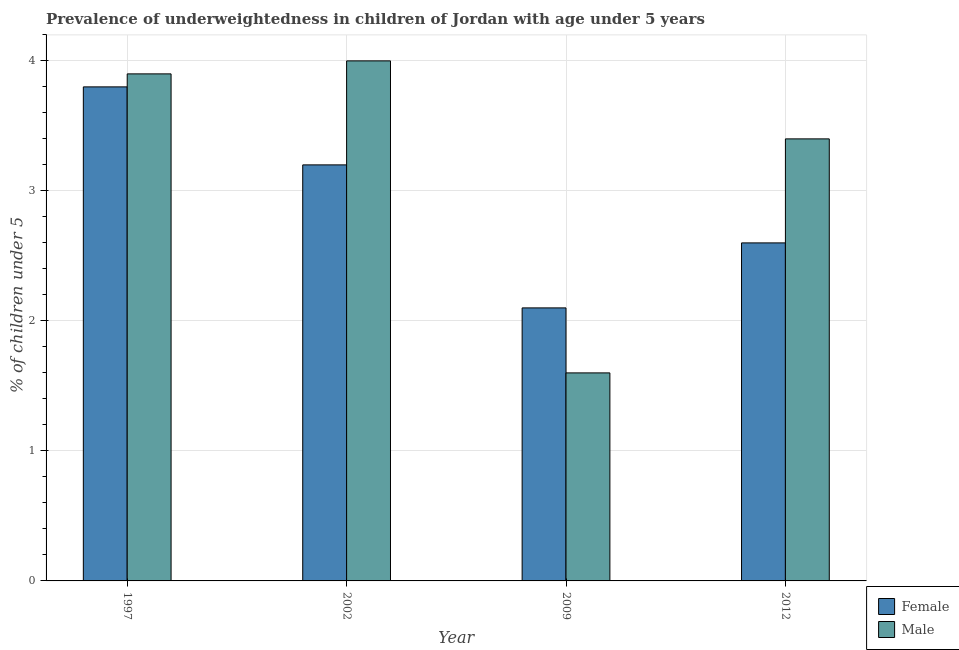How many different coloured bars are there?
Offer a terse response. 2. Are the number of bars on each tick of the X-axis equal?
Give a very brief answer. Yes. How many bars are there on the 2nd tick from the right?
Offer a terse response. 2. In how many cases, is the number of bars for a given year not equal to the number of legend labels?
Your answer should be very brief. 0. What is the percentage of underweighted female children in 2002?
Provide a short and direct response. 3.2. Across all years, what is the maximum percentage of underweighted male children?
Offer a terse response. 4. Across all years, what is the minimum percentage of underweighted female children?
Offer a very short reply. 2.1. What is the total percentage of underweighted male children in the graph?
Your response must be concise. 12.9. What is the difference between the percentage of underweighted female children in 1997 and that in 2002?
Provide a succinct answer. 0.6. What is the difference between the percentage of underweighted female children in 2012 and the percentage of underweighted male children in 2002?
Give a very brief answer. -0.6. What is the average percentage of underweighted male children per year?
Ensure brevity in your answer.  3.23. In how many years, is the percentage of underweighted female children greater than 3.6 %?
Give a very brief answer. 1. What is the ratio of the percentage of underweighted male children in 1997 to that in 2002?
Make the answer very short. 0.98. What is the difference between the highest and the second highest percentage of underweighted male children?
Your answer should be compact. 0.1. What is the difference between the highest and the lowest percentage of underweighted female children?
Provide a short and direct response. 1.7. In how many years, is the percentage of underweighted male children greater than the average percentage of underweighted male children taken over all years?
Your answer should be very brief. 3. Is the sum of the percentage of underweighted female children in 2002 and 2009 greater than the maximum percentage of underweighted male children across all years?
Provide a succinct answer. Yes. What does the 2nd bar from the left in 2009 represents?
Provide a short and direct response. Male. What is the difference between two consecutive major ticks on the Y-axis?
Make the answer very short. 1. Are the values on the major ticks of Y-axis written in scientific E-notation?
Your response must be concise. No. Does the graph contain any zero values?
Your answer should be compact. No. How many legend labels are there?
Provide a succinct answer. 2. What is the title of the graph?
Your response must be concise. Prevalence of underweightedness in children of Jordan with age under 5 years. Does "Male labor force" appear as one of the legend labels in the graph?
Provide a short and direct response. No. What is the label or title of the Y-axis?
Make the answer very short.  % of children under 5. What is the  % of children under 5 in Female in 1997?
Ensure brevity in your answer.  3.8. What is the  % of children under 5 of Male in 1997?
Give a very brief answer. 3.9. What is the  % of children under 5 in Female in 2002?
Provide a short and direct response. 3.2. What is the  % of children under 5 in Male in 2002?
Make the answer very short. 4. What is the  % of children under 5 of Female in 2009?
Provide a short and direct response. 2.1. What is the  % of children under 5 in Male in 2009?
Offer a terse response. 1.6. What is the  % of children under 5 in Female in 2012?
Give a very brief answer. 2.6. What is the  % of children under 5 in Male in 2012?
Offer a terse response. 3.4. Across all years, what is the maximum  % of children under 5 of Female?
Your answer should be very brief. 3.8. Across all years, what is the maximum  % of children under 5 in Male?
Provide a short and direct response. 4. Across all years, what is the minimum  % of children under 5 in Female?
Offer a terse response. 2.1. Across all years, what is the minimum  % of children under 5 in Male?
Your answer should be compact. 1.6. What is the difference between the  % of children under 5 in Female in 1997 and that in 2002?
Provide a succinct answer. 0.6. What is the difference between the  % of children under 5 in Female in 1997 and that in 2009?
Ensure brevity in your answer.  1.7. What is the difference between the  % of children under 5 in Female in 1997 and that in 2012?
Make the answer very short. 1.2. What is the difference between the  % of children under 5 of Male in 1997 and that in 2012?
Make the answer very short. 0.5. What is the difference between the  % of children under 5 of Female in 2002 and that in 2009?
Your answer should be compact. 1.1. What is the difference between the  % of children under 5 in Female in 2009 and that in 2012?
Your answer should be compact. -0.5. What is the difference between the  % of children under 5 of Male in 2009 and that in 2012?
Provide a short and direct response. -1.8. What is the difference between the  % of children under 5 in Female in 1997 and the  % of children under 5 in Male in 2009?
Offer a very short reply. 2.2. What is the difference between the  % of children under 5 in Female in 2002 and the  % of children under 5 in Male in 2009?
Provide a short and direct response. 1.6. What is the difference between the  % of children under 5 in Female in 2002 and the  % of children under 5 in Male in 2012?
Keep it short and to the point. -0.2. What is the difference between the  % of children under 5 in Female in 2009 and the  % of children under 5 in Male in 2012?
Offer a terse response. -1.3. What is the average  % of children under 5 in Female per year?
Your response must be concise. 2.92. What is the average  % of children under 5 in Male per year?
Offer a terse response. 3.23. In the year 1997, what is the difference between the  % of children under 5 of Female and  % of children under 5 of Male?
Offer a very short reply. -0.1. What is the ratio of the  % of children under 5 of Female in 1997 to that in 2002?
Your response must be concise. 1.19. What is the ratio of the  % of children under 5 of Male in 1997 to that in 2002?
Make the answer very short. 0.97. What is the ratio of the  % of children under 5 of Female in 1997 to that in 2009?
Offer a terse response. 1.81. What is the ratio of the  % of children under 5 of Male in 1997 to that in 2009?
Keep it short and to the point. 2.44. What is the ratio of the  % of children under 5 of Female in 1997 to that in 2012?
Provide a short and direct response. 1.46. What is the ratio of the  % of children under 5 in Male in 1997 to that in 2012?
Provide a short and direct response. 1.15. What is the ratio of the  % of children under 5 of Female in 2002 to that in 2009?
Your response must be concise. 1.52. What is the ratio of the  % of children under 5 in Male in 2002 to that in 2009?
Your answer should be very brief. 2.5. What is the ratio of the  % of children under 5 in Female in 2002 to that in 2012?
Provide a short and direct response. 1.23. What is the ratio of the  % of children under 5 of Male in 2002 to that in 2012?
Offer a terse response. 1.18. What is the ratio of the  % of children under 5 of Female in 2009 to that in 2012?
Provide a succinct answer. 0.81. What is the ratio of the  % of children under 5 in Male in 2009 to that in 2012?
Make the answer very short. 0.47. What is the difference between the highest and the lowest  % of children under 5 in Female?
Offer a very short reply. 1.7. 